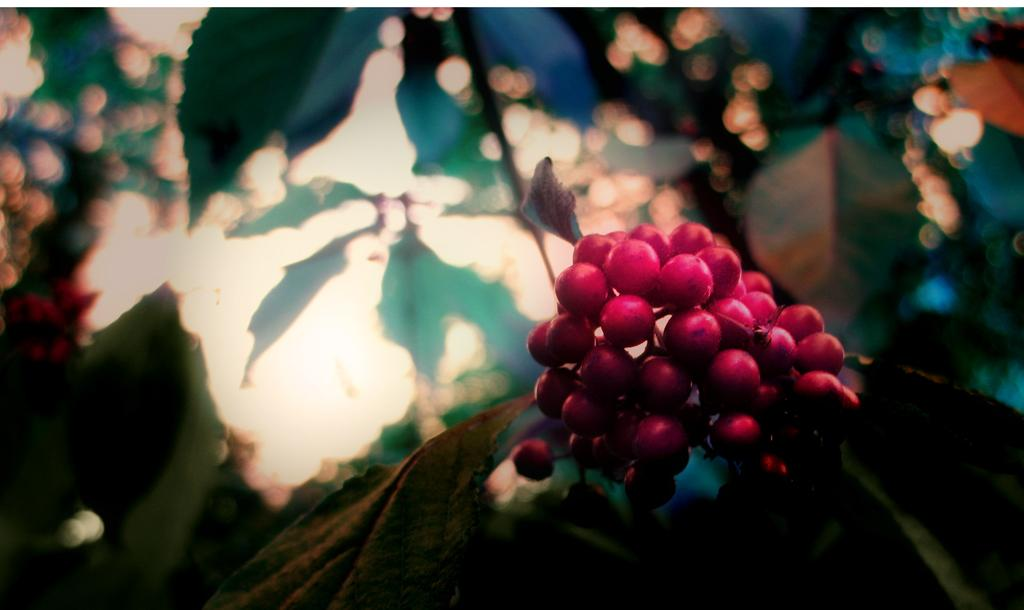What type of food can be seen in the image? There are fruits in the image. What color are the fruits in the image? The fruits are in red color. What can be seen in the background of the image? There are leaves in the background of the image. What color are the leaves in the image? The leaves are in green color. What part of the natural environment is visible in the image? The sky is visible in the image. What color is the sky in the image? The sky is in white color. Can you see your aunt's face in the image? There is no face or person present in the image, as it features fruits, leaves, and the sky. 